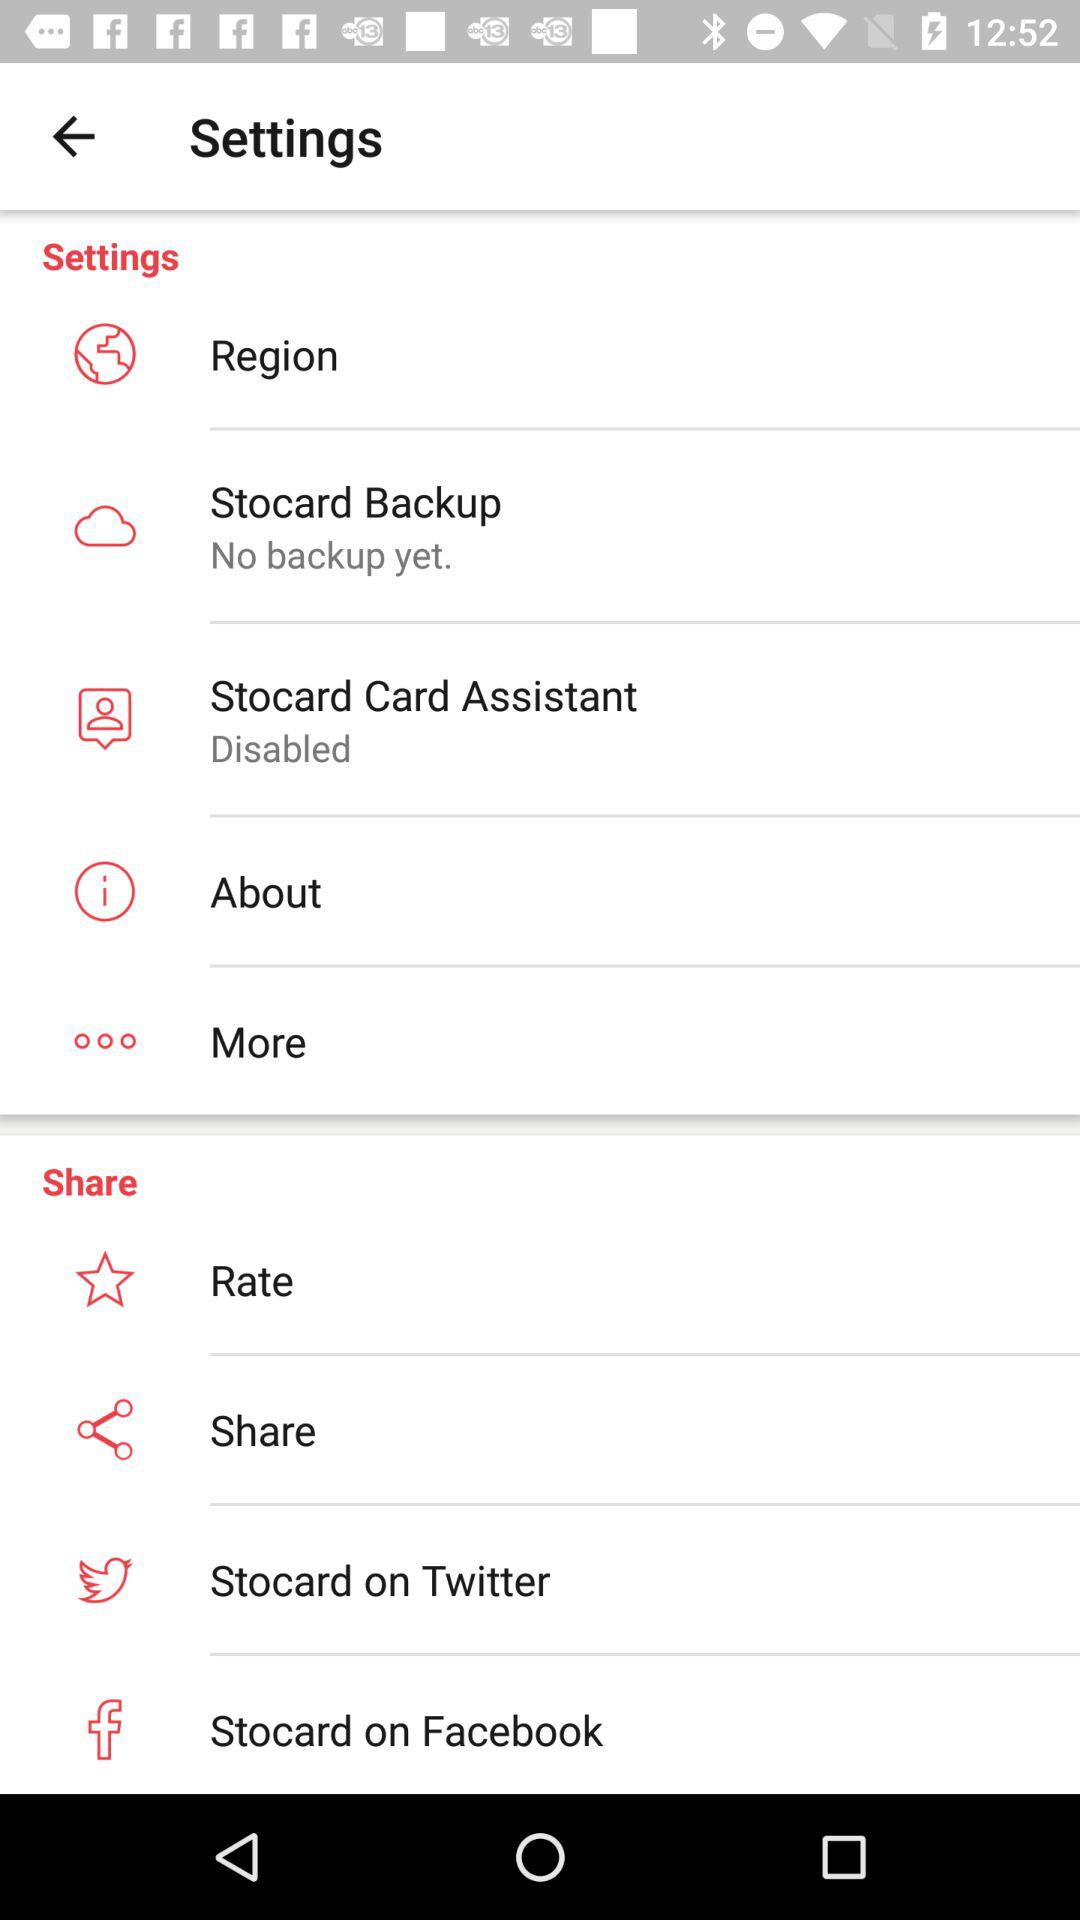On what social platforms is Stocard available? The Stocard is available on Twitter. 